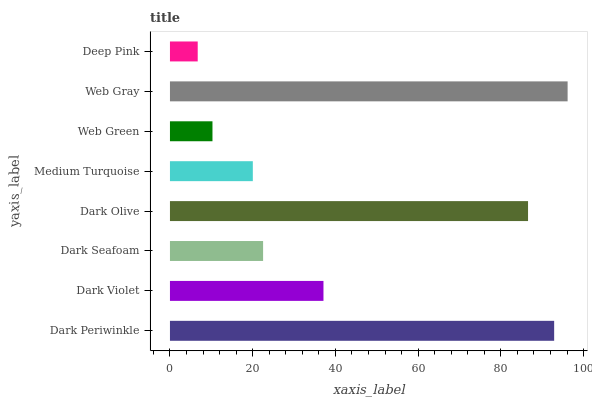Is Deep Pink the minimum?
Answer yes or no. Yes. Is Web Gray the maximum?
Answer yes or no. Yes. Is Dark Violet the minimum?
Answer yes or no. No. Is Dark Violet the maximum?
Answer yes or no. No. Is Dark Periwinkle greater than Dark Violet?
Answer yes or no. Yes. Is Dark Violet less than Dark Periwinkle?
Answer yes or no. Yes. Is Dark Violet greater than Dark Periwinkle?
Answer yes or no. No. Is Dark Periwinkle less than Dark Violet?
Answer yes or no. No. Is Dark Violet the high median?
Answer yes or no. Yes. Is Dark Seafoam the low median?
Answer yes or no. Yes. Is Deep Pink the high median?
Answer yes or no. No. Is Dark Olive the low median?
Answer yes or no. No. 